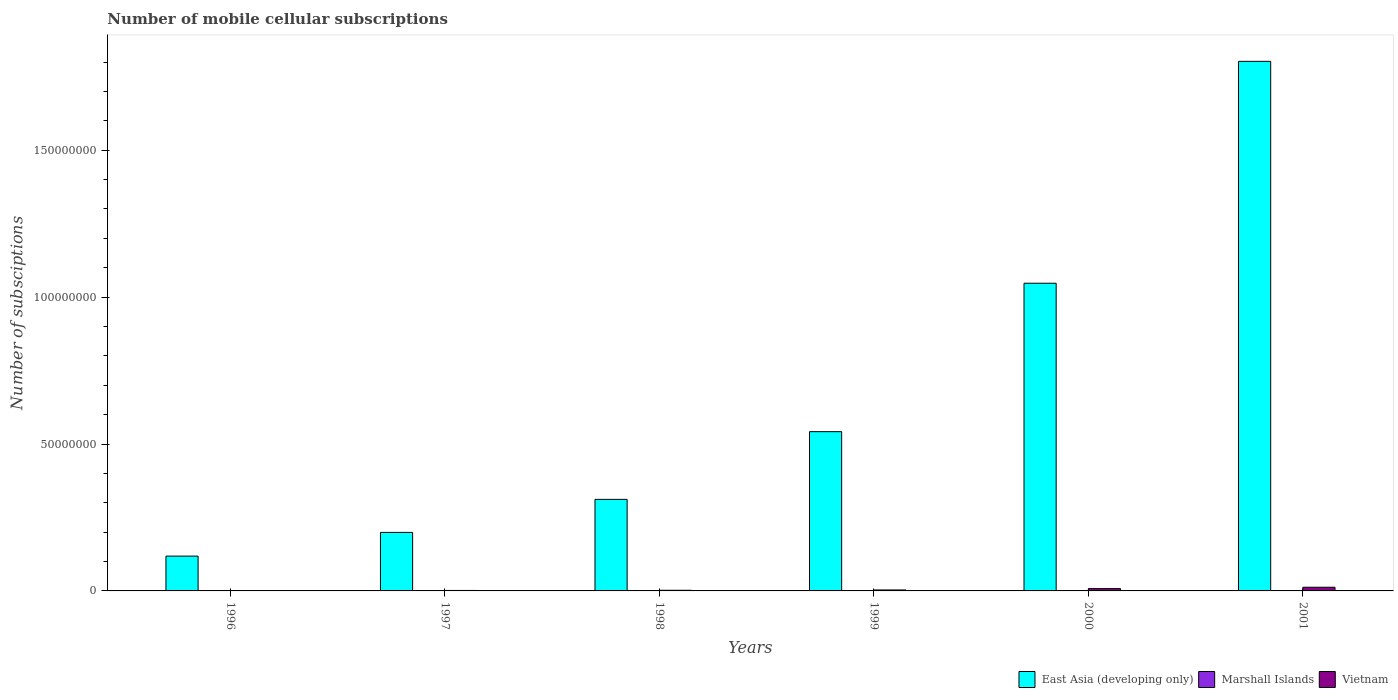How many different coloured bars are there?
Your answer should be compact. 3. How many groups of bars are there?
Keep it short and to the point. 6. Are the number of bars per tick equal to the number of legend labels?
Offer a terse response. Yes. Are the number of bars on each tick of the X-axis equal?
Offer a very short reply. Yes. How many bars are there on the 4th tick from the left?
Your answer should be compact. 3. How many bars are there on the 1st tick from the right?
Offer a very short reply. 3. What is the number of mobile cellular subscriptions in East Asia (developing only) in 2000?
Make the answer very short. 1.05e+08. Across all years, what is the maximum number of mobile cellular subscriptions in East Asia (developing only)?
Provide a succinct answer. 1.80e+08. Across all years, what is the minimum number of mobile cellular subscriptions in Vietnam?
Your answer should be compact. 6.89e+04. In which year was the number of mobile cellular subscriptions in Marshall Islands maximum?
Your answer should be compact. 2001. What is the total number of mobile cellular subscriptions in East Asia (developing only) in the graph?
Provide a succinct answer. 4.02e+08. What is the difference between the number of mobile cellular subscriptions in Marshall Islands in 1998 and that in 2001?
Keep it short and to the point. -144. What is the difference between the number of mobile cellular subscriptions in East Asia (developing only) in 2001 and the number of mobile cellular subscriptions in Vietnam in 1996?
Your response must be concise. 1.80e+08. What is the average number of mobile cellular subscriptions in Marshall Islands per year?
Make the answer very short. 425.83. In the year 1998, what is the difference between the number of mobile cellular subscriptions in Vietnam and number of mobile cellular subscriptions in East Asia (developing only)?
Your response must be concise. -3.09e+07. What is the ratio of the number of mobile cellular subscriptions in Marshall Islands in 1999 to that in 2001?
Your answer should be compact. 0.91. Is the difference between the number of mobile cellular subscriptions in Vietnam in 1996 and 2001 greater than the difference between the number of mobile cellular subscriptions in East Asia (developing only) in 1996 and 2001?
Offer a very short reply. Yes. What is the difference between the highest and the second highest number of mobile cellular subscriptions in East Asia (developing only)?
Provide a short and direct response. 7.55e+07. What is the difference between the highest and the lowest number of mobile cellular subscriptions in East Asia (developing only)?
Ensure brevity in your answer.  1.68e+08. In how many years, is the number of mobile cellular subscriptions in Marshall Islands greater than the average number of mobile cellular subscriptions in Marshall Islands taken over all years?
Your answer should be compact. 4. What does the 1st bar from the left in 1997 represents?
Your response must be concise. East Asia (developing only). What does the 1st bar from the right in 2001 represents?
Keep it short and to the point. Vietnam. Is it the case that in every year, the sum of the number of mobile cellular subscriptions in Marshall Islands and number of mobile cellular subscriptions in Vietnam is greater than the number of mobile cellular subscriptions in East Asia (developing only)?
Your response must be concise. No. How many bars are there?
Your answer should be compact. 18. What is the difference between two consecutive major ticks on the Y-axis?
Your answer should be very brief. 5.00e+07. Are the values on the major ticks of Y-axis written in scientific E-notation?
Your response must be concise. No. Does the graph contain any zero values?
Your answer should be very brief. No. Does the graph contain grids?
Give a very brief answer. No. How are the legend labels stacked?
Give a very brief answer. Horizontal. What is the title of the graph?
Your response must be concise. Number of mobile cellular subscriptions. What is the label or title of the Y-axis?
Your answer should be compact. Number of subsciptions. What is the Number of subsciptions of East Asia (developing only) in 1996?
Your answer should be compact. 1.19e+07. What is the Number of subsciptions of Marshall Islands in 1996?
Your answer should be very brief. 365. What is the Number of subsciptions in Vietnam in 1996?
Offer a very short reply. 6.89e+04. What is the Number of subsciptions of East Asia (developing only) in 1997?
Give a very brief answer. 1.99e+07. What is the Number of subsciptions of Marshall Islands in 1997?
Keep it short and to the point. 466. What is the Number of subsciptions in Vietnam in 1997?
Make the answer very short. 1.60e+05. What is the Number of subsciptions of East Asia (developing only) in 1998?
Your answer should be compact. 3.12e+07. What is the Number of subsciptions of Marshall Islands in 1998?
Offer a very short reply. 345. What is the Number of subsciptions in Vietnam in 1998?
Provide a succinct answer. 2.23e+05. What is the Number of subsciptions in East Asia (developing only) in 1999?
Provide a short and direct response. 5.42e+07. What is the Number of subsciptions of Marshall Islands in 1999?
Make the answer very short. 443. What is the Number of subsciptions of Vietnam in 1999?
Your response must be concise. 3.29e+05. What is the Number of subsciptions of East Asia (developing only) in 2000?
Offer a terse response. 1.05e+08. What is the Number of subsciptions in Marshall Islands in 2000?
Provide a short and direct response. 447. What is the Number of subsciptions in Vietnam in 2000?
Your response must be concise. 7.89e+05. What is the Number of subsciptions in East Asia (developing only) in 2001?
Ensure brevity in your answer.  1.80e+08. What is the Number of subsciptions of Marshall Islands in 2001?
Keep it short and to the point. 489. What is the Number of subsciptions in Vietnam in 2001?
Provide a succinct answer. 1.25e+06. Across all years, what is the maximum Number of subsciptions of East Asia (developing only)?
Provide a succinct answer. 1.80e+08. Across all years, what is the maximum Number of subsciptions in Marshall Islands?
Your response must be concise. 489. Across all years, what is the maximum Number of subsciptions in Vietnam?
Give a very brief answer. 1.25e+06. Across all years, what is the minimum Number of subsciptions of East Asia (developing only)?
Your response must be concise. 1.19e+07. Across all years, what is the minimum Number of subsciptions of Marshall Islands?
Your answer should be compact. 345. Across all years, what is the minimum Number of subsciptions in Vietnam?
Keep it short and to the point. 6.89e+04. What is the total Number of subsciptions of East Asia (developing only) in the graph?
Offer a very short reply. 4.02e+08. What is the total Number of subsciptions in Marshall Islands in the graph?
Give a very brief answer. 2555. What is the total Number of subsciptions of Vietnam in the graph?
Keep it short and to the point. 2.82e+06. What is the difference between the Number of subsciptions in East Asia (developing only) in 1996 and that in 1997?
Offer a terse response. -8.07e+06. What is the difference between the Number of subsciptions in Marshall Islands in 1996 and that in 1997?
Give a very brief answer. -101. What is the difference between the Number of subsciptions in Vietnam in 1996 and that in 1997?
Provide a short and direct response. -9.15e+04. What is the difference between the Number of subsciptions of East Asia (developing only) in 1996 and that in 1998?
Provide a short and direct response. -1.93e+07. What is the difference between the Number of subsciptions in Vietnam in 1996 and that in 1998?
Provide a short and direct response. -1.54e+05. What is the difference between the Number of subsciptions of East Asia (developing only) in 1996 and that in 1999?
Your answer should be very brief. -4.24e+07. What is the difference between the Number of subsciptions of Marshall Islands in 1996 and that in 1999?
Offer a terse response. -78. What is the difference between the Number of subsciptions in Vietnam in 1996 and that in 1999?
Your answer should be very brief. -2.60e+05. What is the difference between the Number of subsciptions of East Asia (developing only) in 1996 and that in 2000?
Keep it short and to the point. -9.29e+07. What is the difference between the Number of subsciptions of Marshall Islands in 1996 and that in 2000?
Offer a very short reply. -82. What is the difference between the Number of subsciptions in Vietnam in 1996 and that in 2000?
Your answer should be very brief. -7.20e+05. What is the difference between the Number of subsciptions in East Asia (developing only) in 1996 and that in 2001?
Ensure brevity in your answer.  -1.68e+08. What is the difference between the Number of subsciptions in Marshall Islands in 1996 and that in 2001?
Your answer should be very brief. -124. What is the difference between the Number of subsciptions of Vietnam in 1996 and that in 2001?
Offer a very short reply. -1.18e+06. What is the difference between the Number of subsciptions of East Asia (developing only) in 1997 and that in 1998?
Your answer should be very brief. -1.12e+07. What is the difference between the Number of subsciptions in Marshall Islands in 1997 and that in 1998?
Your answer should be compact. 121. What is the difference between the Number of subsciptions of Vietnam in 1997 and that in 1998?
Provide a succinct answer. -6.22e+04. What is the difference between the Number of subsciptions in East Asia (developing only) in 1997 and that in 1999?
Your answer should be very brief. -3.43e+07. What is the difference between the Number of subsciptions of Marshall Islands in 1997 and that in 1999?
Your answer should be very brief. 23. What is the difference between the Number of subsciptions of Vietnam in 1997 and that in 1999?
Provide a short and direct response. -1.68e+05. What is the difference between the Number of subsciptions of East Asia (developing only) in 1997 and that in 2000?
Offer a very short reply. -8.48e+07. What is the difference between the Number of subsciptions in Vietnam in 1997 and that in 2000?
Make the answer very short. -6.28e+05. What is the difference between the Number of subsciptions in East Asia (developing only) in 1997 and that in 2001?
Make the answer very short. -1.60e+08. What is the difference between the Number of subsciptions in Vietnam in 1997 and that in 2001?
Provide a succinct answer. -1.09e+06. What is the difference between the Number of subsciptions of East Asia (developing only) in 1998 and that in 1999?
Provide a succinct answer. -2.30e+07. What is the difference between the Number of subsciptions in Marshall Islands in 1998 and that in 1999?
Ensure brevity in your answer.  -98. What is the difference between the Number of subsciptions of Vietnam in 1998 and that in 1999?
Your answer should be very brief. -1.06e+05. What is the difference between the Number of subsciptions of East Asia (developing only) in 1998 and that in 2000?
Make the answer very short. -7.36e+07. What is the difference between the Number of subsciptions in Marshall Islands in 1998 and that in 2000?
Provide a succinct answer. -102. What is the difference between the Number of subsciptions in Vietnam in 1998 and that in 2000?
Offer a very short reply. -5.66e+05. What is the difference between the Number of subsciptions of East Asia (developing only) in 1998 and that in 2001?
Ensure brevity in your answer.  -1.49e+08. What is the difference between the Number of subsciptions in Marshall Islands in 1998 and that in 2001?
Your answer should be very brief. -144. What is the difference between the Number of subsciptions of Vietnam in 1998 and that in 2001?
Offer a very short reply. -1.03e+06. What is the difference between the Number of subsciptions of East Asia (developing only) in 1999 and that in 2000?
Your answer should be very brief. -5.05e+07. What is the difference between the Number of subsciptions of Marshall Islands in 1999 and that in 2000?
Provide a succinct answer. -4. What is the difference between the Number of subsciptions in Vietnam in 1999 and that in 2000?
Keep it short and to the point. -4.60e+05. What is the difference between the Number of subsciptions in East Asia (developing only) in 1999 and that in 2001?
Keep it short and to the point. -1.26e+08. What is the difference between the Number of subsciptions in Marshall Islands in 1999 and that in 2001?
Give a very brief answer. -46. What is the difference between the Number of subsciptions of Vietnam in 1999 and that in 2001?
Ensure brevity in your answer.  -9.23e+05. What is the difference between the Number of subsciptions of East Asia (developing only) in 2000 and that in 2001?
Provide a short and direct response. -7.55e+07. What is the difference between the Number of subsciptions of Marshall Islands in 2000 and that in 2001?
Your response must be concise. -42. What is the difference between the Number of subsciptions in Vietnam in 2000 and that in 2001?
Give a very brief answer. -4.63e+05. What is the difference between the Number of subsciptions in East Asia (developing only) in 1996 and the Number of subsciptions in Marshall Islands in 1997?
Provide a succinct answer. 1.19e+07. What is the difference between the Number of subsciptions of East Asia (developing only) in 1996 and the Number of subsciptions of Vietnam in 1997?
Ensure brevity in your answer.  1.17e+07. What is the difference between the Number of subsciptions of Marshall Islands in 1996 and the Number of subsciptions of Vietnam in 1997?
Offer a terse response. -1.60e+05. What is the difference between the Number of subsciptions in East Asia (developing only) in 1996 and the Number of subsciptions in Marshall Islands in 1998?
Offer a terse response. 1.19e+07. What is the difference between the Number of subsciptions of East Asia (developing only) in 1996 and the Number of subsciptions of Vietnam in 1998?
Provide a succinct answer. 1.16e+07. What is the difference between the Number of subsciptions of Marshall Islands in 1996 and the Number of subsciptions of Vietnam in 1998?
Provide a short and direct response. -2.22e+05. What is the difference between the Number of subsciptions of East Asia (developing only) in 1996 and the Number of subsciptions of Marshall Islands in 1999?
Offer a very short reply. 1.19e+07. What is the difference between the Number of subsciptions of East Asia (developing only) in 1996 and the Number of subsciptions of Vietnam in 1999?
Your response must be concise. 1.15e+07. What is the difference between the Number of subsciptions of Marshall Islands in 1996 and the Number of subsciptions of Vietnam in 1999?
Provide a succinct answer. -3.28e+05. What is the difference between the Number of subsciptions of East Asia (developing only) in 1996 and the Number of subsciptions of Marshall Islands in 2000?
Offer a terse response. 1.19e+07. What is the difference between the Number of subsciptions of East Asia (developing only) in 1996 and the Number of subsciptions of Vietnam in 2000?
Your answer should be compact. 1.11e+07. What is the difference between the Number of subsciptions in Marshall Islands in 1996 and the Number of subsciptions in Vietnam in 2000?
Your answer should be compact. -7.88e+05. What is the difference between the Number of subsciptions in East Asia (developing only) in 1996 and the Number of subsciptions in Marshall Islands in 2001?
Ensure brevity in your answer.  1.19e+07. What is the difference between the Number of subsciptions of East Asia (developing only) in 1996 and the Number of subsciptions of Vietnam in 2001?
Provide a short and direct response. 1.06e+07. What is the difference between the Number of subsciptions of Marshall Islands in 1996 and the Number of subsciptions of Vietnam in 2001?
Provide a succinct answer. -1.25e+06. What is the difference between the Number of subsciptions in East Asia (developing only) in 1997 and the Number of subsciptions in Marshall Islands in 1998?
Your answer should be compact. 1.99e+07. What is the difference between the Number of subsciptions in East Asia (developing only) in 1997 and the Number of subsciptions in Vietnam in 1998?
Provide a succinct answer. 1.97e+07. What is the difference between the Number of subsciptions of Marshall Islands in 1997 and the Number of subsciptions of Vietnam in 1998?
Ensure brevity in your answer.  -2.22e+05. What is the difference between the Number of subsciptions of East Asia (developing only) in 1997 and the Number of subsciptions of Marshall Islands in 1999?
Your answer should be very brief. 1.99e+07. What is the difference between the Number of subsciptions in East Asia (developing only) in 1997 and the Number of subsciptions in Vietnam in 1999?
Make the answer very short. 1.96e+07. What is the difference between the Number of subsciptions of Marshall Islands in 1997 and the Number of subsciptions of Vietnam in 1999?
Ensure brevity in your answer.  -3.28e+05. What is the difference between the Number of subsciptions in East Asia (developing only) in 1997 and the Number of subsciptions in Marshall Islands in 2000?
Provide a succinct answer. 1.99e+07. What is the difference between the Number of subsciptions in East Asia (developing only) in 1997 and the Number of subsciptions in Vietnam in 2000?
Give a very brief answer. 1.91e+07. What is the difference between the Number of subsciptions in Marshall Islands in 1997 and the Number of subsciptions in Vietnam in 2000?
Provide a succinct answer. -7.88e+05. What is the difference between the Number of subsciptions in East Asia (developing only) in 1997 and the Number of subsciptions in Marshall Islands in 2001?
Provide a short and direct response. 1.99e+07. What is the difference between the Number of subsciptions in East Asia (developing only) in 1997 and the Number of subsciptions in Vietnam in 2001?
Ensure brevity in your answer.  1.87e+07. What is the difference between the Number of subsciptions of Marshall Islands in 1997 and the Number of subsciptions of Vietnam in 2001?
Your answer should be compact. -1.25e+06. What is the difference between the Number of subsciptions of East Asia (developing only) in 1998 and the Number of subsciptions of Marshall Islands in 1999?
Offer a very short reply. 3.12e+07. What is the difference between the Number of subsciptions in East Asia (developing only) in 1998 and the Number of subsciptions in Vietnam in 1999?
Your answer should be very brief. 3.08e+07. What is the difference between the Number of subsciptions in Marshall Islands in 1998 and the Number of subsciptions in Vietnam in 1999?
Provide a short and direct response. -3.28e+05. What is the difference between the Number of subsciptions of East Asia (developing only) in 1998 and the Number of subsciptions of Marshall Islands in 2000?
Give a very brief answer. 3.12e+07. What is the difference between the Number of subsciptions of East Asia (developing only) in 1998 and the Number of subsciptions of Vietnam in 2000?
Ensure brevity in your answer.  3.04e+07. What is the difference between the Number of subsciptions in Marshall Islands in 1998 and the Number of subsciptions in Vietnam in 2000?
Offer a very short reply. -7.88e+05. What is the difference between the Number of subsciptions of East Asia (developing only) in 1998 and the Number of subsciptions of Marshall Islands in 2001?
Give a very brief answer. 3.12e+07. What is the difference between the Number of subsciptions of East Asia (developing only) in 1998 and the Number of subsciptions of Vietnam in 2001?
Provide a short and direct response. 2.99e+07. What is the difference between the Number of subsciptions in Marshall Islands in 1998 and the Number of subsciptions in Vietnam in 2001?
Keep it short and to the point. -1.25e+06. What is the difference between the Number of subsciptions in East Asia (developing only) in 1999 and the Number of subsciptions in Marshall Islands in 2000?
Offer a very short reply. 5.42e+07. What is the difference between the Number of subsciptions of East Asia (developing only) in 1999 and the Number of subsciptions of Vietnam in 2000?
Your response must be concise. 5.34e+07. What is the difference between the Number of subsciptions of Marshall Islands in 1999 and the Number of subsciptions of Vietnam in 2000?
Your answer should be compact. -7.88e+05. What is the difference between the Number of subsciptions of East Asia (developing only) in 1999 and the Number of subsciptions of Marshall Islands in 2001?
Ensure brevity in your answer.  5.42e+07. What is the difference between the Number of subsciptions of East Asia (developing only) in 1999 and the Number of subsciptions of Vietnam in 2001?
Your answer should be very brief. 5.30e+07. What is the difference between the Number of subsciptions of Marshall Islands in 1999 and the Number of subsciptions of Vietnam in 2001?
Keep it short and to the point. -1.25e+06. What is the difference between the Number of subsciptions in East Asia (developing only) in 2000 and the Number of subsciptions in Marshall Islands in 2001?
Keep it short and to the point. 1.05e+08. What is the difference between the Number of subsciptions of East Asia (developing only) in 2000 and the Number of subsciptions of Vietnam in 2001?
Your answer should be compact. 1.03e+08. What is the difference between the Number of subsciptions in Marshall Islands in 2000 and the Number of subsciptions in Vietnam in 2001?
Provide a short and direct response. -1.25e+06. What is the average Number of subsciptions of East Asia (developing only) per year?
Provide a succinct answer. 6.70e+07. What is the average Number of subsciptions of Marshall Islands per year?
Give a very brief answer. 425.83. What is the average Number of subsciptions in Vietnam per year?
Provide a succinct answer. 4.70e+05. In the year 1996, what is the difference between the Number of subsciptions of East Asia (developing only) and Number of subsciptions of Marshall Islands?
Your answer should be compact. 1.19e+07. In the year 1996, what is the difference between the Number of subsciptions in East Asia (developing only) and Number of subsciptions in Vietnam?
Your response must be concise. 1.18e+07. In the year 1996, what is the difference between the Number of subsciptions in Marshall Islands and Number of subsciptions in Vietnam?
Your answer should be compact. -6.85e+04. In the year 1997, what is the difference between the Number of subsciptions of East Asia (developing only) and Number of subsciptions of Marshall Islands?
Give a very brief answer. 1.99e+07. In the year 1997, what is the difference between the Number of subsciptions of East Asia (developing only) and Number of subsciptions of Vietnam?
Offer a very short reply. 1.98e+07. In the year 1997, what is the difference between the Number of subsciptions in Marshall Islands and Number of subsciptions in Vietnam?
Your answer should be very brief. -1.60e+05. In the year 1998, what is the difference between the Number of subsciptions of East Asia (developing only) and Number of subsciptions of Marshall Islands?
Make the answer very short. 3.12e+07. In the year 1998, what is the difference between the Number of subsciptions of East Asia (developing only) and Number of subsciptions of Vietnam?
Make the answer very short. 3.09e+07. In the year 1998, what is the difference between the Number of subsciptions of Marshall Islands and Number of subsciptions of Vietnam?
Keep it short and to the point. -2.22e+05. In the year 1999, what is the difference between the Number of subsciptions in East Asia (developing only) and Number of subsciptions in Marshall Islands?
Keep it short and to the point. 5.42e+07. In the year 1999, what is the difference between the Number of subsciptions of East Asia (developing only) and Number of subsciptions of Vietnam?
Your answer should be very brief. 5.39e+07. In the year 1999, what is the difference between the Number of subsciptions in Marshall Islands and Number of subsciptions in Vietnam?
Your answer should be compact. -3.28e+05. In the year 2000, what is the difference between the Number of subsciptions in East Asia (developing only) and Number of subsciptions in Marshall Islands?
Your response must be concise. 1.05e+08. In the year 2000, what is the difference between the Number of subsciptions of East Asia (developing only) and Number of subsciptions of Vietnam?
Your response must be concise. 1.04e+08. In the year 2000, what is the difference between the Number of subsciptions in Marshall Islands and Number of subsciptions in Vietnam?
Your answer should be compact. -7.88e+05. In the year 2001, what is the difference between the Number of subsciptions in East Asia (developing only) and Number of subsciptions in Marshall Islands?
Your answer should be compact. 1.80e+08. In the year 2001, what is the difference between the Number of subsciptions in East Asia (developing only) and Number of subsciptions in Vietnam?
Your answer should be very brief. 1.79e+08. In the year 2001, what is the difference between the Number of subsciptions of Marshall Islands and Number of subsciptions of Vietnam?
Your response must be concise. -1.25e+06. What is the ratio of the Number of subsciptions in East Asia (developing only) in 1996 to that in 1997?
Offer a terse response. 0.59. What is the ratio of the Number of subsciptions in Marshall Islands in 1996 to that in 1997?
Your response must be concise. 0.78. What is the ratio of the Number of subsciptions in Vietnam in 1996 to that in 1997?
Make the answer very short. 0.43. What is the ratio of the Number of subsciptions in East Asia (developing only) in 1996 to that in 1998?
Provide a succinct answer. 0.38. What is the ratio of the Number of subsciptions in Marshall Islands in 1996 to that in 1998?
Provide a short and direct response. 1.06. What is the ratio of the Number of subsciptions of Vietnam in 1996 to that in 1998?
Give a very brief answer. 0.31. What is the ratio of the Number of subsciptions in East Asia (developing only) in 1996 to that in 1999?
Your answer should be very brief. 0.22. What is the ratio of the Number of subsciptions of Marshall Islands in 1996 to that in 1999?
Keep it short and to the point. 0.82. What is the ratio of the Number of subsciptions of Vietnam in 1996 to that in 1999?
Make the answer very short. 0.21. What is the ratio of the Number of subsciptions of East Asia (developing only) in 1996 to that in 2000?
Offer a very short reply. 0.11. What is the ratio of the Number of subsciptions of Marshall Islands in 1996 to that in 2000?
Offer a terse response. 0.82. What is the ratio of the Number of subsciptions of Vietnam in 1996 to that in 2000?
Provide a short and direct response. 0.09. What is the ratio of the Number of subsciptions in East Asia (developing only) in 1996 to that in 2001?
Offer a very short reply. 0.07. What is the ratio of the Number of subsciptions in Marshall Islands in 1996 to that in 2001?
Give a very brief answer. 0.75. What is the ratio of the Number of subsciptions in Vietnam in 1996 to that in 2001?
Give a very brief answer. 0.06. What is the ratio of the Number of subsciptions in East Asia (developing only) in 1997 to that in 1998?
Make the answer very short. 0.64. What is the ratio of the Number of subsciptions of Marshall Islands in 1997 to that in 1998?
Give a very brief answer. 1.35. What is the ratio of the Number of subsciptions in Vietnam in 1997 to that in 1998?
Your answer should be very brief. 0.72. What is the ratio of the Number of subsciptions of East Asia (developing only) in 1997 to that in 1999?
Offer a very short reply. 0.37. What is the ratio of the Number of subsciptions of Marshall Islands in 1997 to that in 1999?
Provide a succinct answer. 1.05. What is the ratio of the Number of subsciptions in Vietnam in 1997 to that in 1999?
Offer a terse response. 0.49. What is the ratio of the Number of subsciptions of East Asia (developing only) in 1997 to that in 2000?
Provide a short and direct response. 0.19. What is the ratio of the Number of subsciptions in Marshall Islands in 1997 to that in 2000?
Provide a succinct answer. 1.04. What is the ratio of the Number of subsciptions of Vietnam in 1997 to that in 2000?
Give a very brief answer. 0.2. What is the ratio of the Number of subsciptions of East Asia (developing only) in 1997 to that in 2001?
Provide a succinct answer. 0.11. What is the ratio of the Number of subsciptions of Marshall Islands in 1997 to that in 2001?
Your response must be concise. 0.95. What is the ratio of the Number of subsciptions in Vietnam in 1997 to that in 2001?
Your answer should be very brief. 0.13. What is the ratio of the Number of subsciptions of East Asia (developing only) in 1998 to that in 1999?
Ensure brevity in your answer.  0.57. What is the ratio of the Number of subsciptions of Marshall Islands in 1998 to that in 1999?
Give a very brief answer. 0.78. What is the ratio of the Number of subsciptions in Vietnam in 1998 to that in 1999?
Your response must be concise. 0.68. What is the ratio of the Number of subsciptions of East Asia (developing only) in 1998 to that in 2000?
Offer a very short reply. 0.3. What is the ratio of the Number of subsciptions of Marshall Islands in 1998 to that in 2000?
Keep it short and to the point. 0.77. What is the ratio of the Number of subsciptions in Vietnam in 1998 to that in 2000?
Offer a very short reply. 0.28. What is the ratio of the Number of subsciptions in East Asia (developing only) in 1998 to that in 2001?
Your answer should be compact. 0.17. What is the ratio of the Number of subsciptions of Marshall Islands in 1998 to that in 2001?
Your answer should be very brief. 0.71. What is the ratio of the Number of subsciptions of Vietnam in 1998 to that in 2001?
Ensure brevity in your answer.  0.18. What is the ratio of the Number of subsciptions of East Asia (developing only) in 1999 to that in 2000?
Your response must be concise. 0.52. What is the ratio of the Number of subsciptions in Marshall Islands in 1999 to that in 2000?
Ensure brevity in your answer.  0.99. What is the ratio of the Number of subsciptions of Vietnam in 1999 to that in 2000?
Your answer should be compact. 0.42. What is the ratio of the Number of subsciptions of East Asia (developing only) in 1999 to that in 2001?
Provide a succinct answer. 0.3. What is the ratio of the Number of subsciptions of Marshall Islands in 1999 to that in 2001?
Make the answer very short. 0.91. What is the ratio of the Number of subsciptions of Vietnam in 1999 to that in 2001?
Offer a terse response. 0.26. What is the ratio of the Number of subsciptions of East Asia (developing only) in 2000 to that in 2001?
Keep it short and to the point. 0.58. What is the ratio of the Number of subsciptions of Marshall Islands in 2000 to that in 2001?
Make the answer very short. 0.91. What is the ratio of the Number of subsciptions of Vietnam in 2000 to that in 2001?
Provide a succinct answer. 0.63. What is the difference between the highest and the second highest Number of subsciptions in East Asia (developing only)?
Offer a terse response. 7.55e+07. What is the difference between the highest and the second highest Number of subsciptions of Vietnam?
Your response must be concise. 4.63e+05. What is the difference between the highest and the lowest Number of subsciptions in East Asia (developing only)?
Your answer should be very brief. 1.68e+08. What is the difference between the highest and the lowest Number of subsciptions in Marshall Islands?
Your response must be concise. 144. What is the difference between the highest and the lowest Number of subsciptions of Vietnam?
Your answer should be compact. 1.18e+06. 